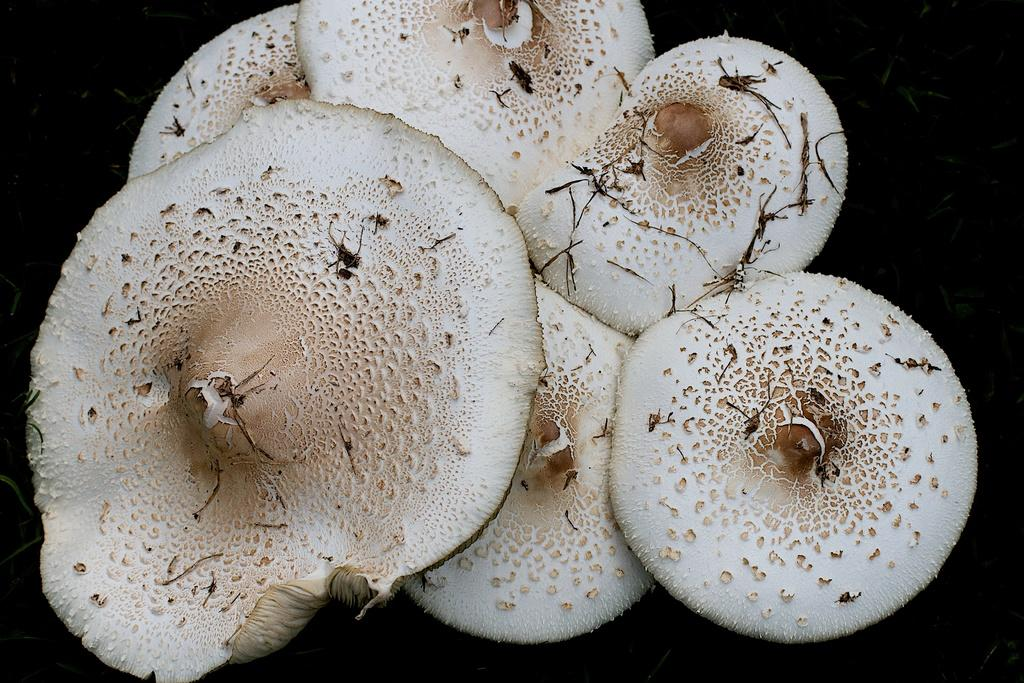What type of fungi can be seen in the image? There are mushrooms in the image. What type of skirt is being worn by the mushroom in the image? There is no skirt or any clothing present in the image, as it features mushrooms. 